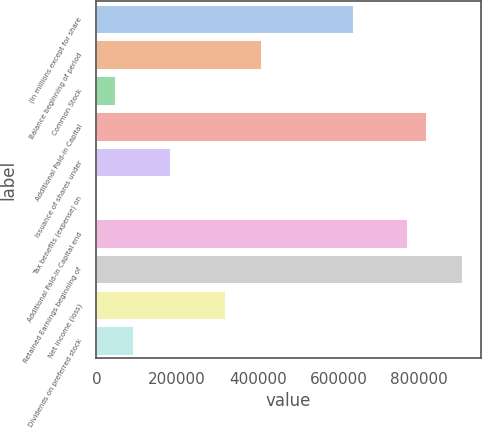Convert chart to OTSL. <chart><loc_0><loc_0><loc_500><loc_500><bar_chart><fcel>(In millions except for share<fcel>Balance beginning of period<fcel>Common Stock<fcel>Additional Paid-in Capital<fcel>Issuance of shares under<fcel>Tax benefits (expense) on<fcel>Additional Paid-in Capital end<fcel>Retained Earnings beginning of<fcel>Net income (loss)<fcel>Dividends on preferred stock<nl><fcel>634605<fcel>407961<fcel>45331.7<fcel>815920<fcel>181318<fcel>3<fcel>770591<fcel>906577<fcel>317304<fcel>90660.4<nl></chart> 